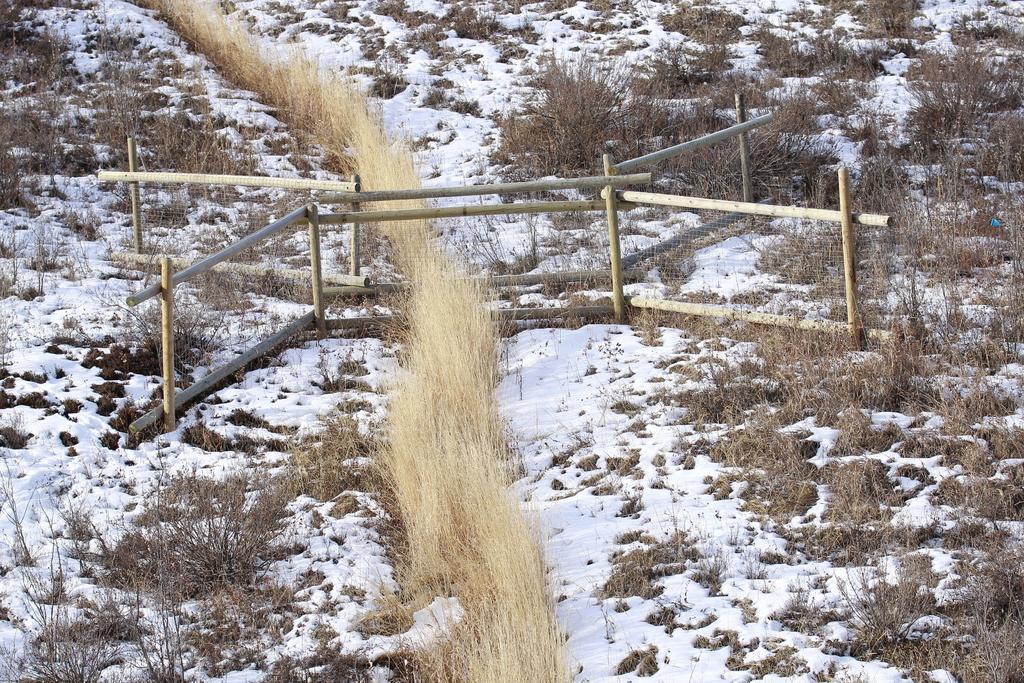What type of fencing can be seen in the image? There is a wooden fencing in the image. What is the weather condition in the image? There is snow visible in the image, indicating a cold or wintry condition. What type of vegetation is present in the image? Dry grass and small plants are in the image. How many sisters are standing near the wooden fencing in the image? There are no sisters present in the image; it only features a wooden fencing, snow, dry grass, and small plants. 